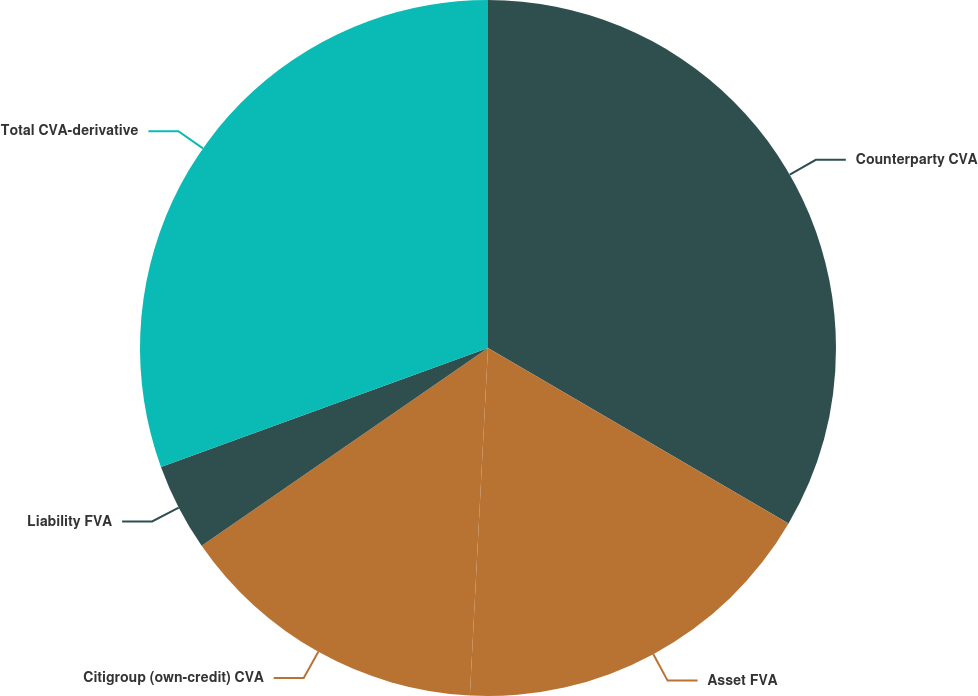Convert chart. <chart><loc_0><loc_0><loc_500><loc_500><pie_chart><fcel>Counterparty CVA<fcel>Asset FVA<fcel>Citigroup (own-credit) CVA<fcel>Liability FVA<fcel>Total CVA-derivative<nl><fcel>33.41%<fcel>17.42%<fcel>14.55%<fcel>4.07%<fcel>30.55%<nl></chart> 